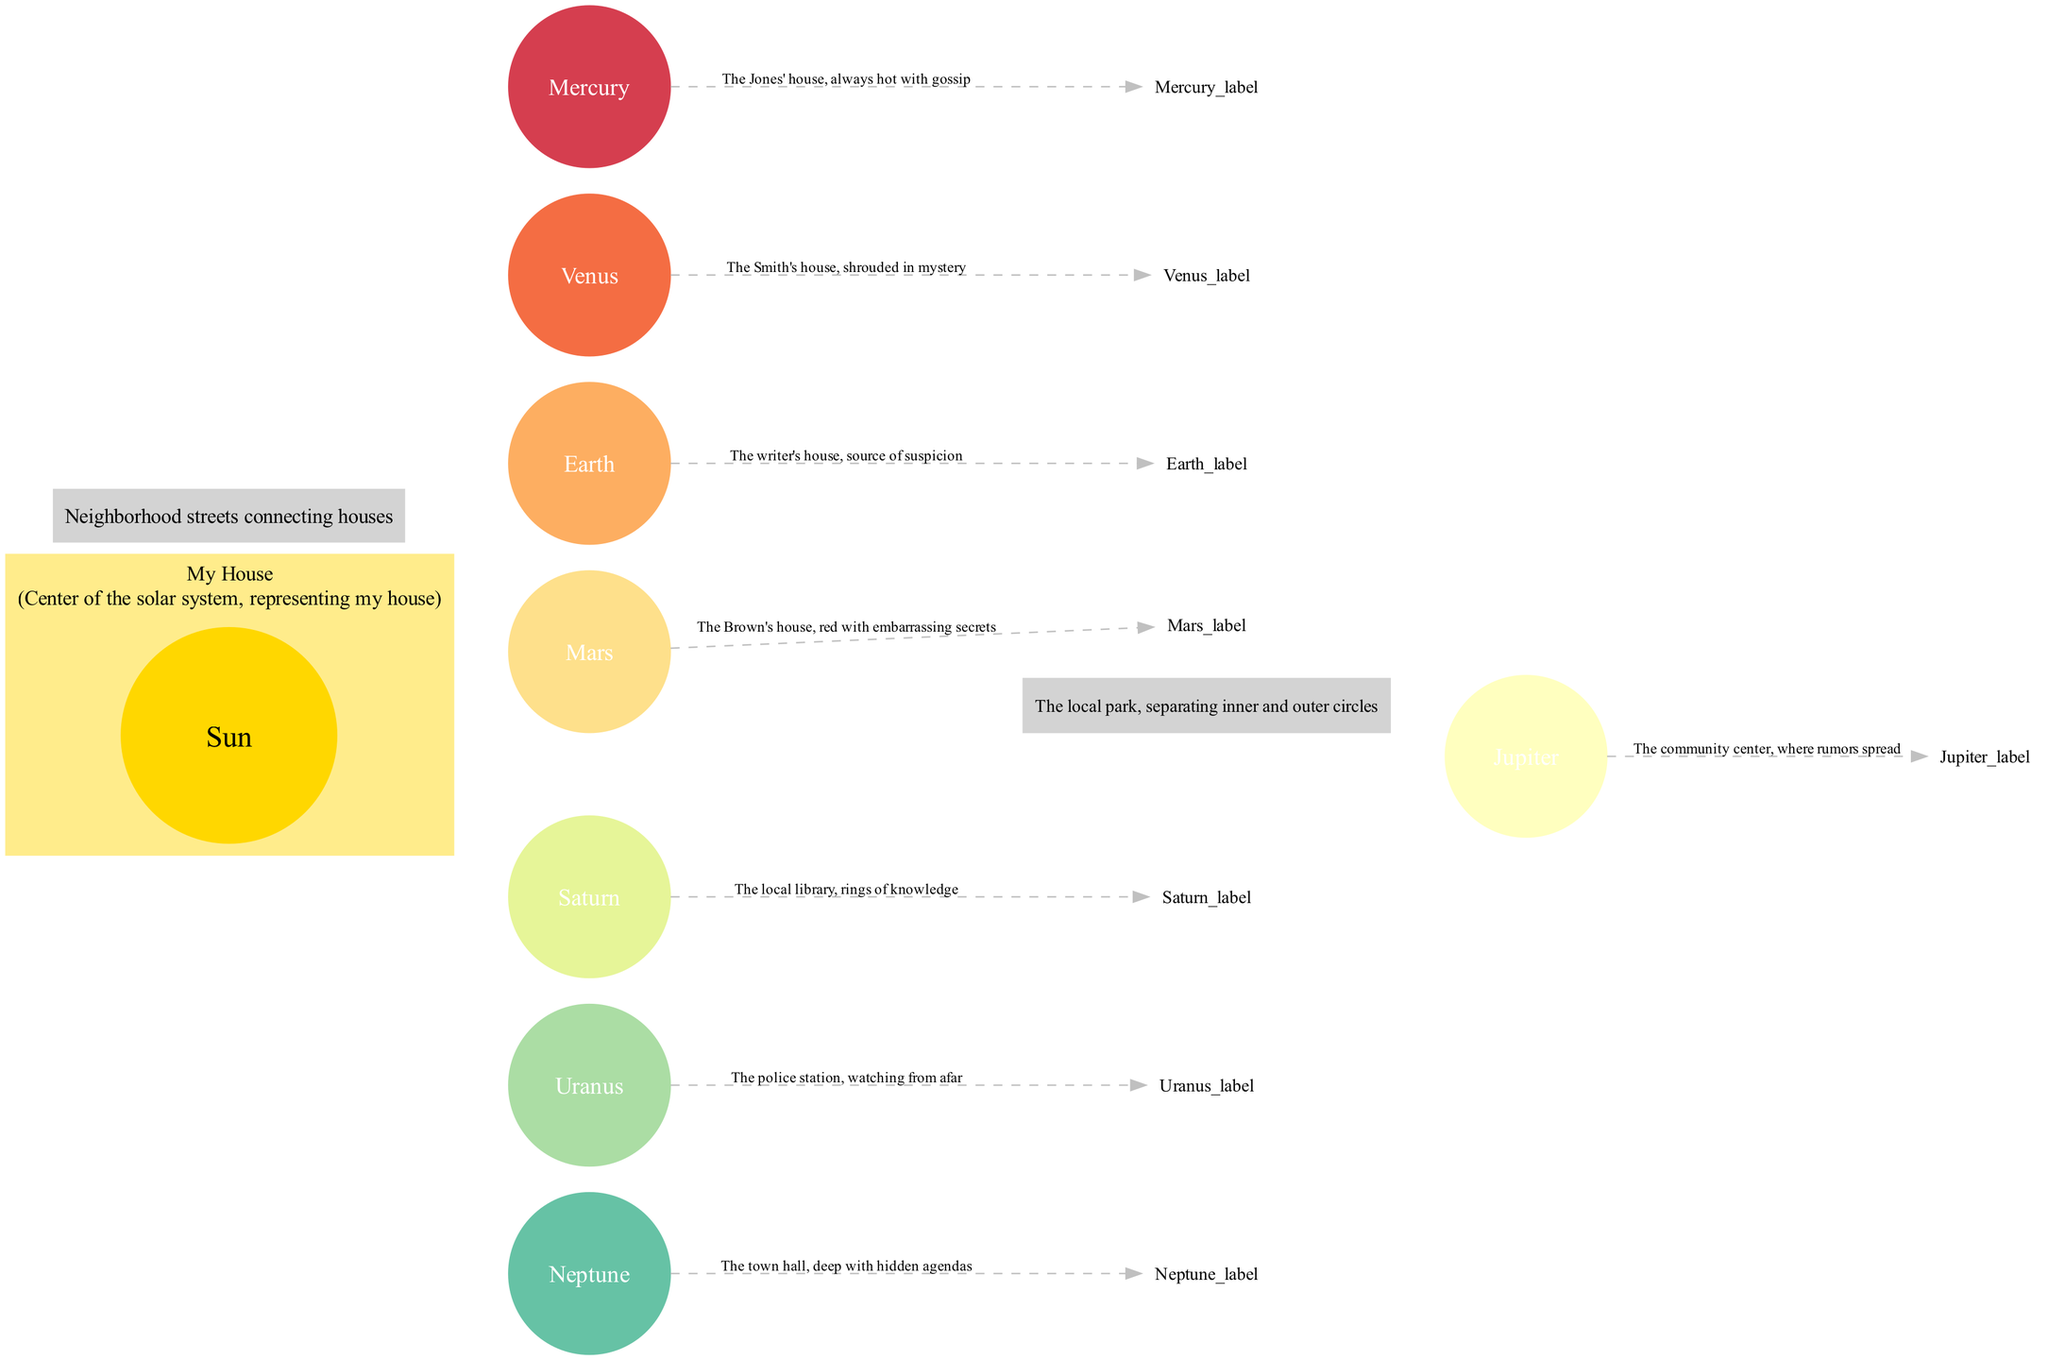What is the name of the central body in the diagram? The central body in the diagram is labeled "Sun," which acts as the center of the solar system and is described as representing the narrator's house.
Answer: Sun How many planets are represented in the diagram? There are eight planets listed in the diagram. Each planet has a corresponding description and name, which contributes to this total count.
Answer: 8 Which house is described as "shrouded in mystery"? The house described as "shrouded in mystery" is Venus. This house has a specific characterization and is named in the context of the diagram.
Answer: Smith's house What does the asteroid belt represent in the diagram? The asteroid belt is labeled as "The local park," which serves a descriptive function within the diagram by separating the inner and outer circles of planets.
Answer: The local park Which house is perceived as "watching from afar"? The house that is perceived as "watching from afar" represents Uranus. This description implies a watchful or observant nature related to its position in the diagram.
Answer: The police station How is the orbit described in the diagram? The orbit is described as "Neighborhood streets connecting houses," indicating how the planets revolve around the Sun similarly to how houses might be connected in a neighborhood layout.
Answer: Neighborhood streets connecting houses Which house is represented as "where rumors spread"? Jupiter is the house represented as "where rumors spread." This description associates Jupiter with a communal aspect of spreading information or gossip.
Answer: The community center What color is the central body (Sun) in the diagram? The color of the central body (Sun) is gold, as indicated by the description in the diagram.
Answer: Gold Which planet's house is associated with "embarrassing secrets"? Mars is the planet's house associated with "red with embarrassing secrets." This specific description characterizes Mars distinctly in the context of the diagram.
Answer: The Brown's house 